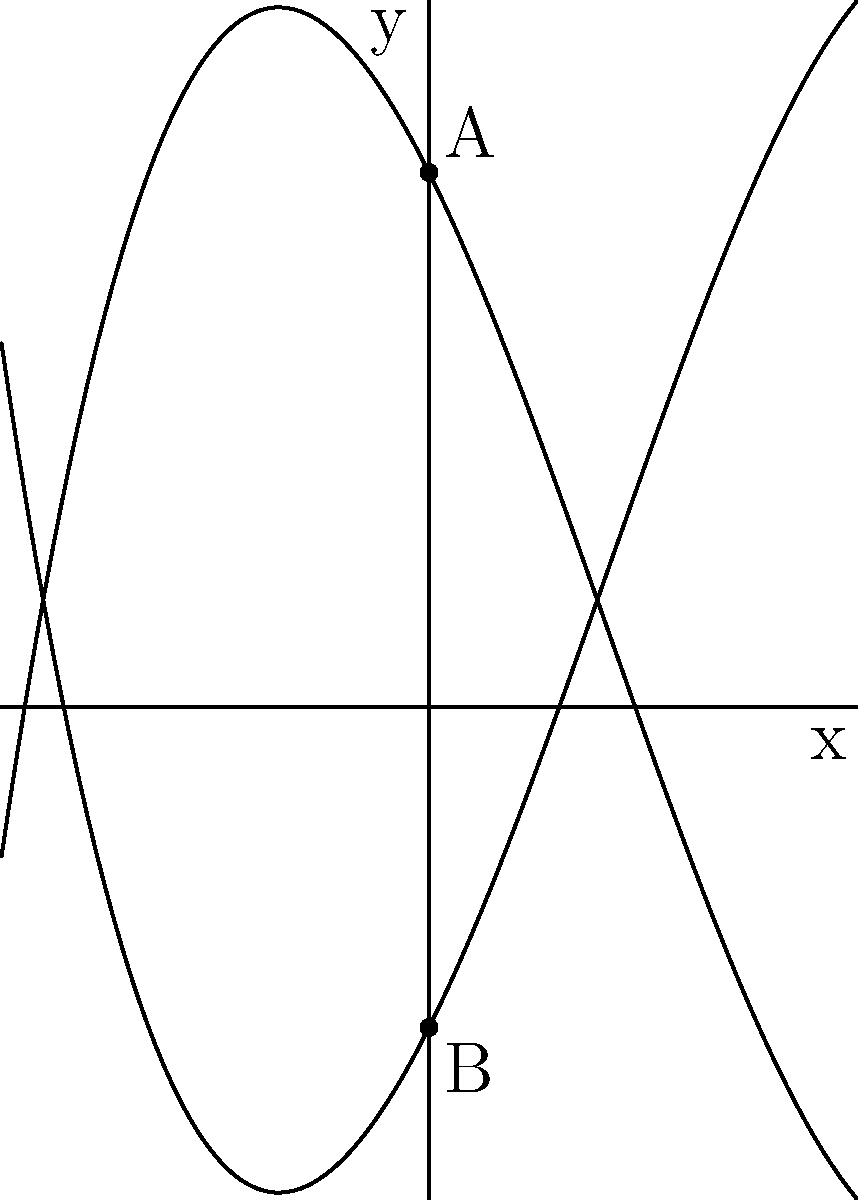In honor of the Frog Constellation Festival in Paris, you've been tasked with plotting a frog-shaped constellation on a coordinate plane. The frog's body is represented by two cubic functions: $f(x)=0.1x^3-0.5x^2-2x+5$ and $g(x)=-0.1x^3+0.5x^2+2x-3$. If point A represents the frog's eye and point B its mouth, what is the vertical distance between these two points? Let's approach this step-by-step:

1) Point A (the frog's eye) is located at the y-intercept of $f(x)$. To find this, we set $x=0$ in the equation of $f(x)$:
   $f(0) = 0.1(0)^3 - 0.5(0)^2 - 2(0) + 5 = 5$
   So, point A is at (0, 5)

2) Point B (the frog's mouth) is located at the y-intercept of $g(x)$. Again, we set $x=0$:
   $g(0) = -0.1(0)^3 + 0.5(0)^2 + 2(0) - 3 = -3$
   So, point B is at (0, -3)

3) The vertical distance between two points is the absolute difference between their y-coordinates.

4) The y-coordinate of A is 5, and the y-coordinate of B is -3.

5) The vertical distance is therefore:
   $|5 - (-3)| = |5 + 3| = |8| = 8$

Therefore, the vertical distance between the frog's eye and mouth is 8 units.
Answer: 8 units 